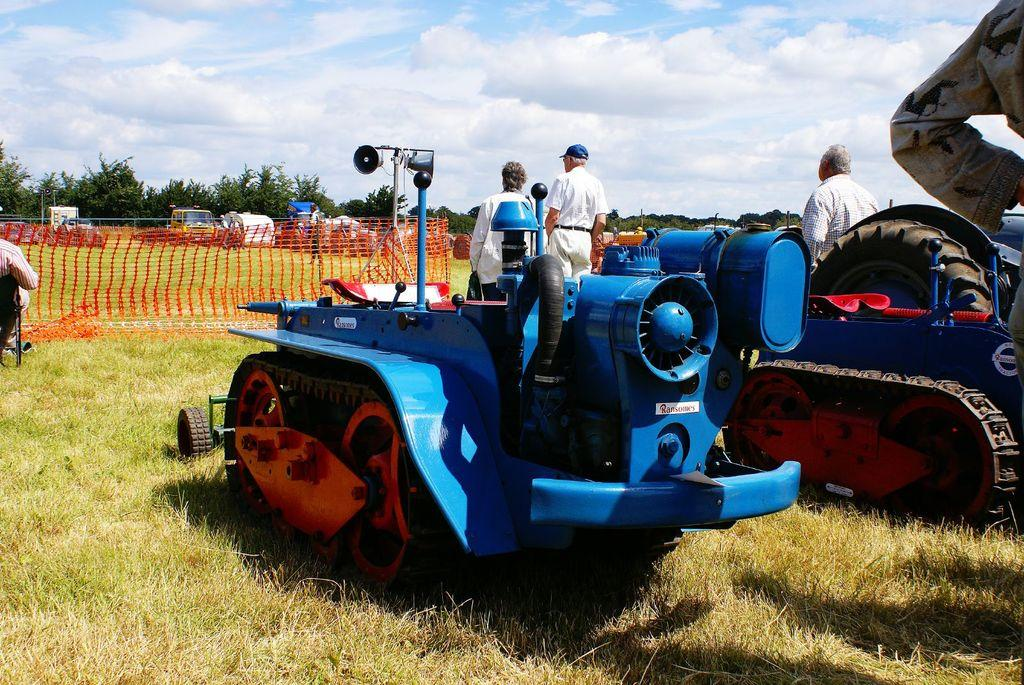How many persons are in the image? There are persons in the image, but the exact number is not specified. What else can be seen in the image besides the persons? There are vehicles, a chair, a speaker, a net, trees, and the sky visible in the image. What type of objects are the vehicles? The specific type of vehicles is not mentioned in the facts. What is the purpose of the speaker in the image? The purpose of the speaker is not specified in the facts. What type of net is present in the image? The type of net is not mentioned in the facts. What is the color of the trees in the image? The color of the trees is not specified in the facts. What type of pest can be seen crawling on the speaker in the image? There is no pest visible on the speaker in the image. 